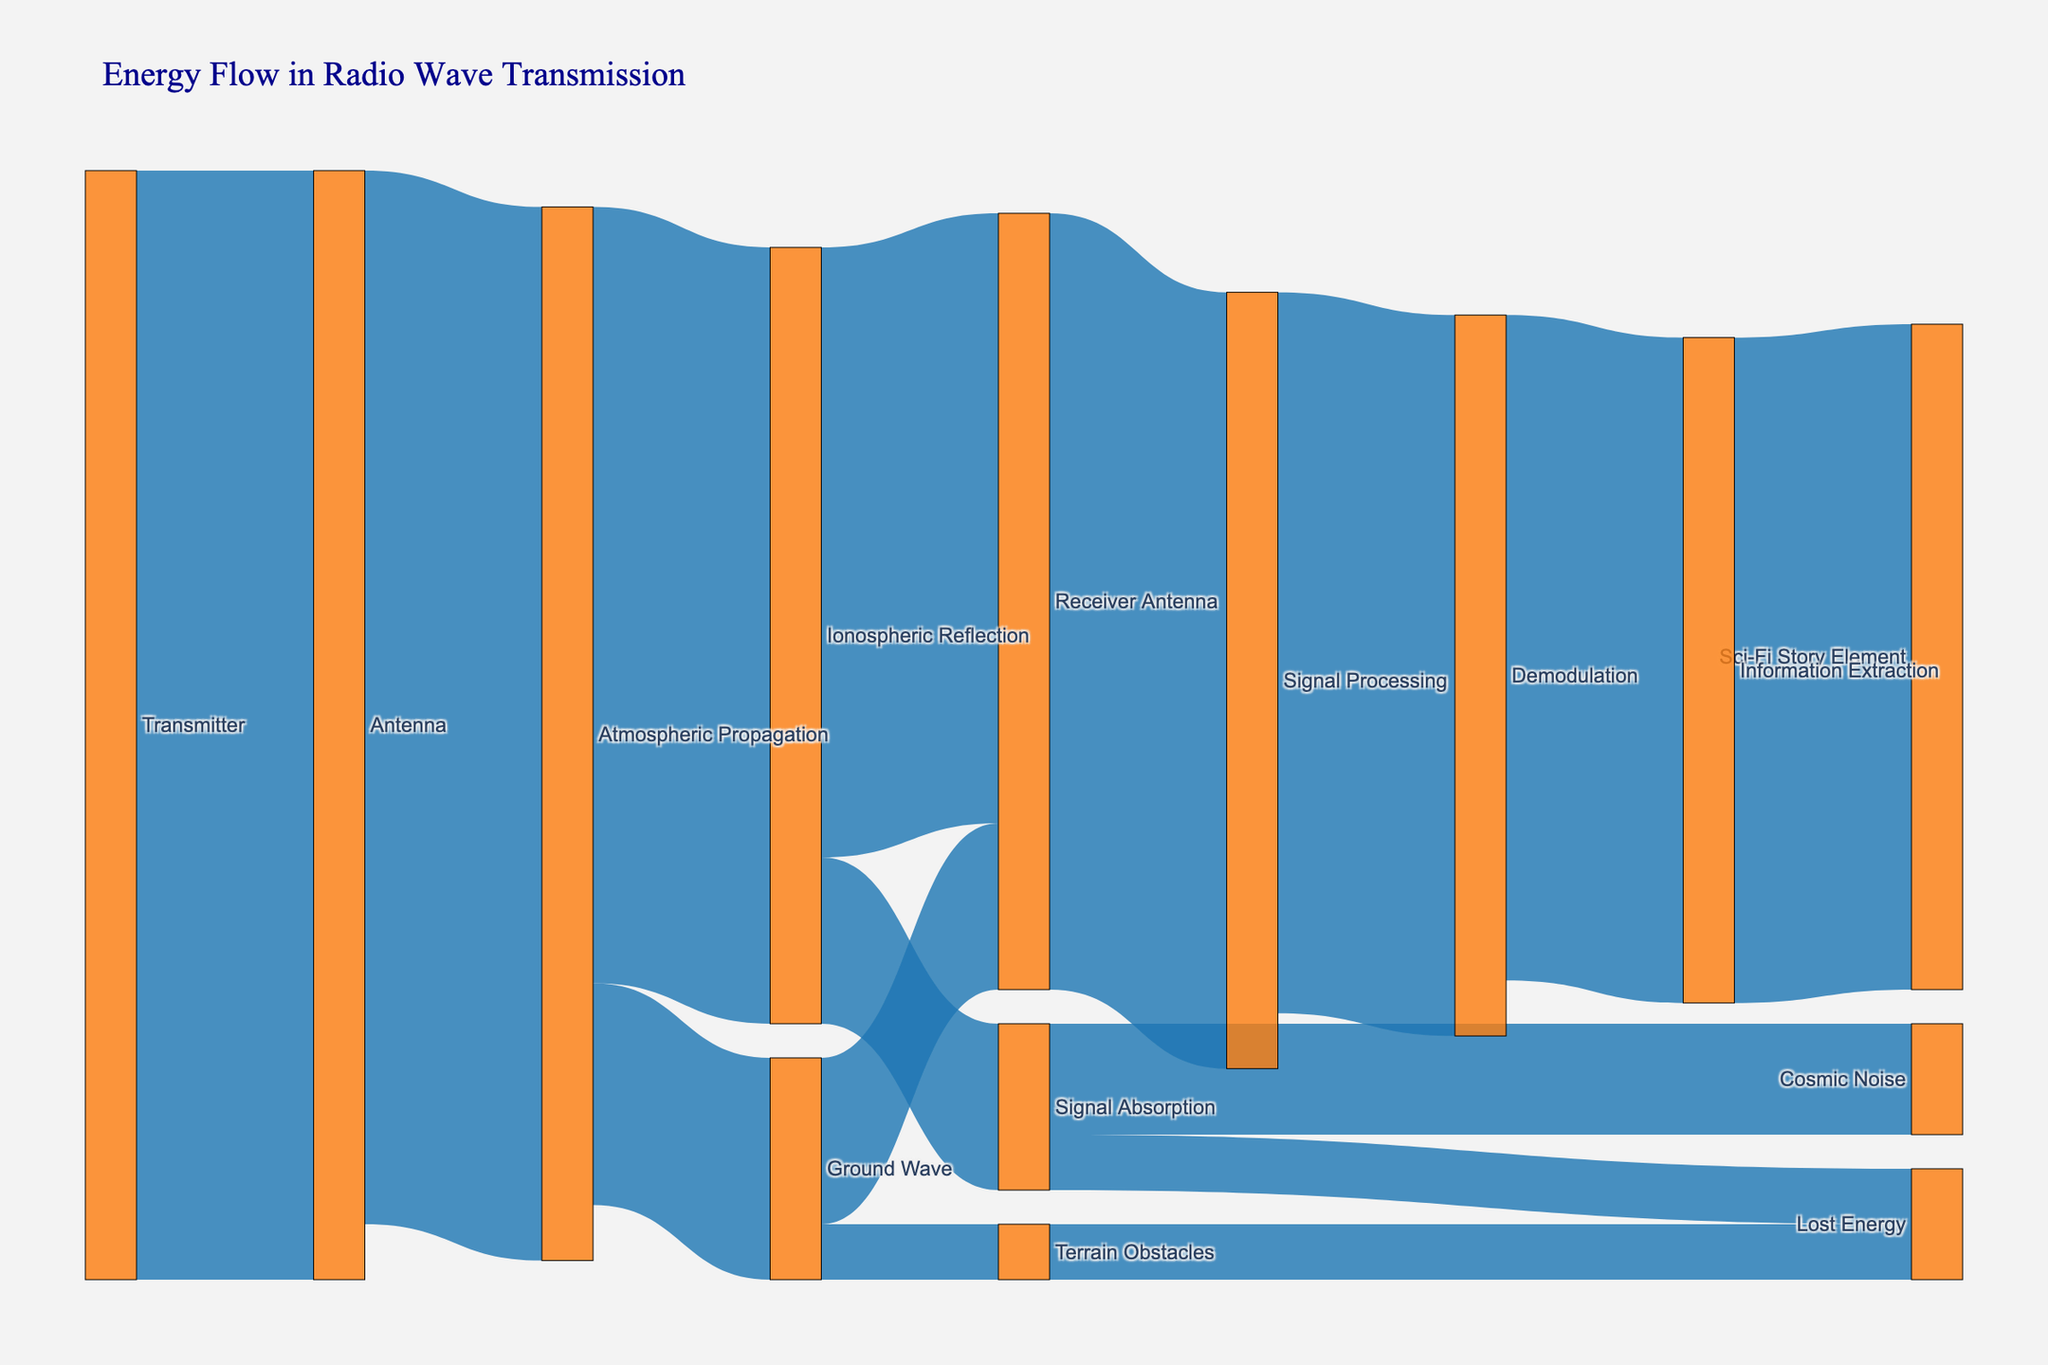What's the title of the figure? The title is displayed at the top of the figure in a larger and distinct font.
Answer: Energy Flow in Radio Wave Transmission Which component receives energy directly from the Transmitter? The first flow from the Transmitter goes to the Antenna, which is indicated by the directed link.
Answer: Antenna How much energy is lost during Atmospheric Propagation? The losses in Atmospheric Propagation are split into Ionospheric Reflection and Ground Wave flows. The total loss can be calculated as 95 (input) - (70 + 20) (outputs total) = 5.
Answer: 5 How much energy reaches the Receiver Antenna via both Ionospheric Reflection and Ground Wave? Sum the values leading to the Receiver Antenna from both paths: 55 from Ionospheric Reflection and 15 from Ground Wave.
Answer: 70 Which path results in the most energy loss before reaching the Receiver Antenna? Compare the energy losses in different paths: Signal Absorption (15), Ionospheric Reflection (70 - 55), Ground Wave (20 - 15). Signal Absorption results in the highest loss before reaching the Receiver Antenna.
Answer: Signal Absorption After the energy reaches the Receiver Antenna, what is the remaining energy until Information Extraction? Follow the path through Signal Processing (70), Demodulation (65), Information Extraction (60). This shows that the remaining energy at each step decreases, leaving 60 in the end.
Answer: 60 Which process utilizes the most energy after it passes through the Receiver Antenna? Upon passing through the Receiver Antenna, energy flows to Signal Processing with 70, the highest single usage.
Answer: Signal Processing How much energy is lost due to Terrain Obstacles? Terrain Obstacles receives 5 from Ground Wave and loses 5 to Lost Energy, indicating a complete loss.
Answer: 5 Which targets receive energy directly from Signal Absorption? The Signal Absorption node has outputs to Cosmic Noise and Lost Energy, as shown by the links.
Answer: Cosmic Noise, Lost Energy 